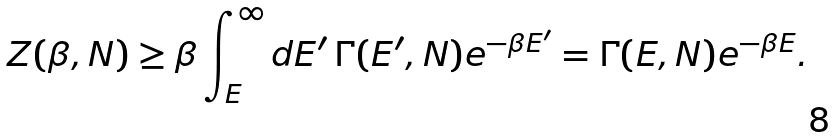Convert formula to latex. <formula><loc_0><loc_0><loc_500><loc_500>Z ( \beta , N ) \geq \beta \int _ { E } ^ { \infty } d E ^ { \prime } \, \Gamma ( E ^ { \prime } , N ) e ^ { - \beta E ^ { \prime } } = \Gamma ( E , N ) e ^ { - \beta E } .</formula> 